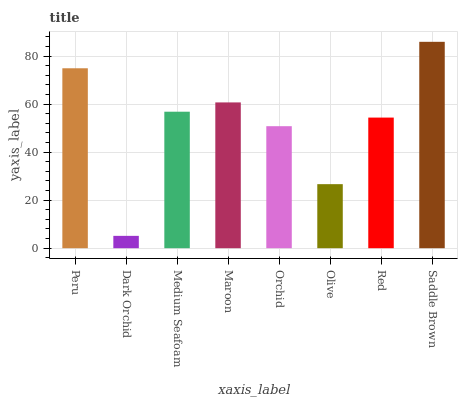Is Dark Orchid the minimum?
Answer yes or no. Yes. Is Saddle Brown the maximum?
Answer yes or no. Yes. Is Medium Seafoam the minimum?
Answer yes or no. No. Is Medium Seafoam the maximum?
Answer yes or no. No. Is Medium Seafoam greater than Dark Orchid?
Answer yes or no. Yes. Is Dark Orchid less than Medium Seafoam?
Answer yes or no. Yes. Is Dark Orchid greater than Medium Seafoam?
Answer yes or no. No. Is Medium Seafoam less than Dark Orchid?
Answer yes or no. No. Is Medium Seafoam the high median?
Answer yes or no. Yes. Is Red the low median?
Answer yes or no. Yes. Is Saddle Brown the high median?
Answer yes or no. No. Is Medium Seafoam the low median?
Answer yes or no. No. 